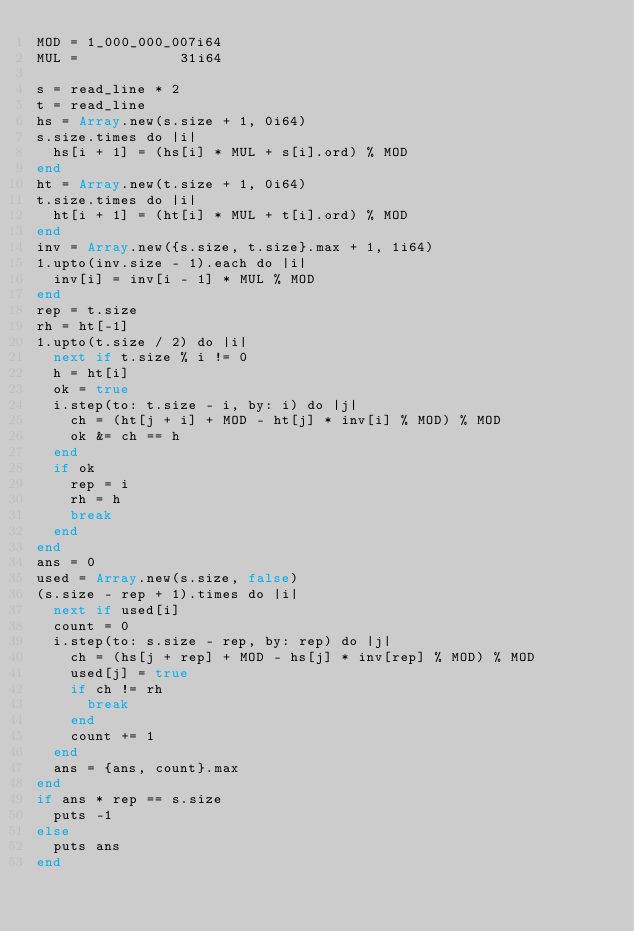Convert code to text. <code><loc_0><loc_0><loc_500><loc_500><_Crystal_>MOD = 1_000_000_007i64
MUL =            31i64

s = read_line * 2
t = read_line
hs = Array.new(s.size + 1, 0i64)
s.size.times do |i|
  hs[i + 1] = (hs[i] * MUL + s[i].ord) % MOD
end
ht = Array.new(t.size + 1, 0i64)
t.size.times do |i|
  ht[i + 1] = (ht[i] * MUL + t[i].ord) % MOD
end
inv = Array.new({s.size, t.size}.max + 1, 1i64)
1.upto(inv.size - 1).each do |i|
  inv[i] = inv[i - 1] * MUL % MOD
end
rep = t.size
rh = ht[-1]
1.upto(t.size / 2) do |i|
  next if t.size % i != 0
  h = ht[i]
  ok = true
  i.step(to: t.size - i, by: i) do |j|
    ch = (ht[j + i] + MOD - ht[j] * inv[i] % MOD) % MOD
    ok &= ch == h
  end
  if ok
    rep = i
    rh = h
    break
  end
end
ans = 0
used = Array.new(s.size, false)
(s.size - rep + 1).times do |i|
  next if used[i]
  count = 0
  i.step(to: s.size - rep, by: rep) do |j|
    ch = (hs[j + rep] + MOD - hs[j] * inv[rep] % MOD) % MOD
    used[j] = true
    if ch != rh
      break
    end
    count += 1
  end
  ans = {ans, count}.max
end
if ans * rep == s.size
  puts -1
else
  puts ans
end
</code> 